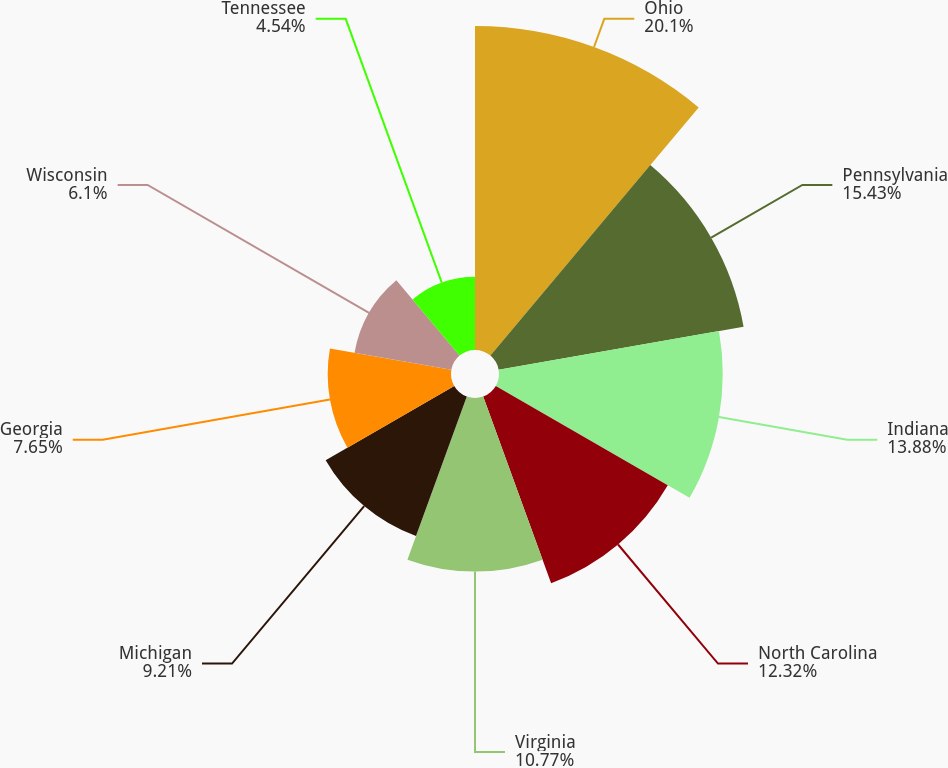Convert chart. <chart><loc_0><loc_0><loc_500><loc_500><pie_chart><fcel>Ohio<fcel>Pennsylvania<fcel>Indiana<fcel>North Carolina<fcel>Virginia<fcel>Michigan<fcel>Georgia<fcel>Wisconsin<fcel>Tennessee<nl><fcel>20.1%<fcel>15.43%<fcel>13.88%<fcel>12.32%<fcel>10.77%<fcel>9.21%<fcel>7.65%<fcel>6.1%<fcel>4.54%<nl></chart> 